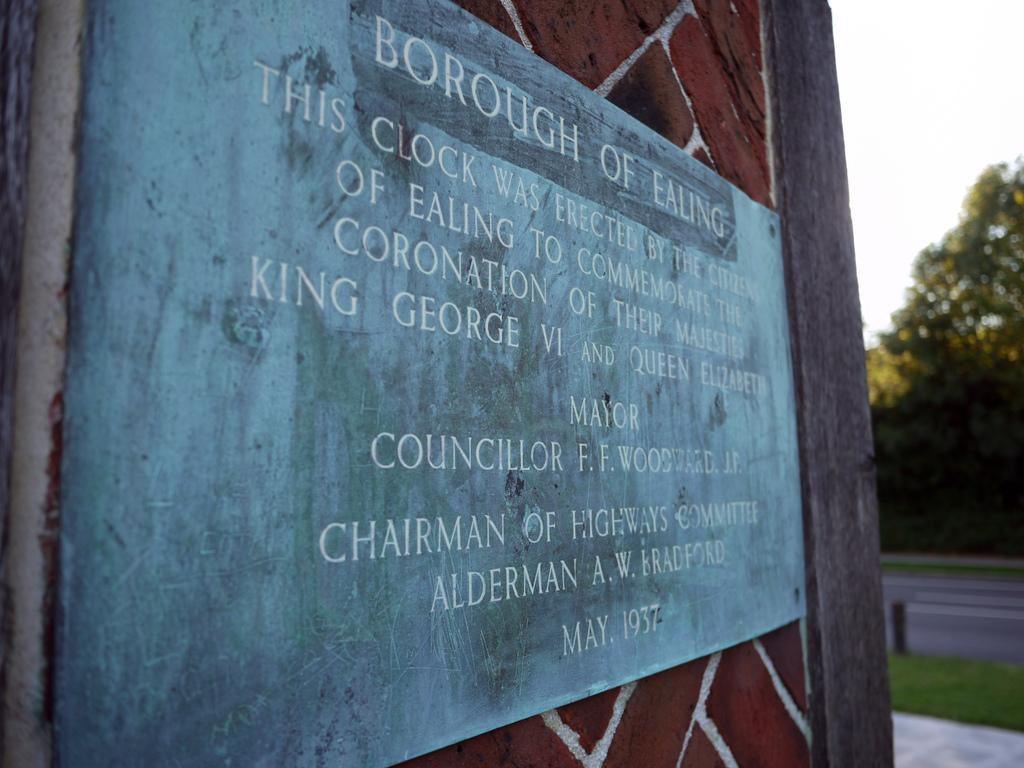<image>
Provide a brief description of the given image. The sign from the Borough of Ealing explains why a clock was erected. 